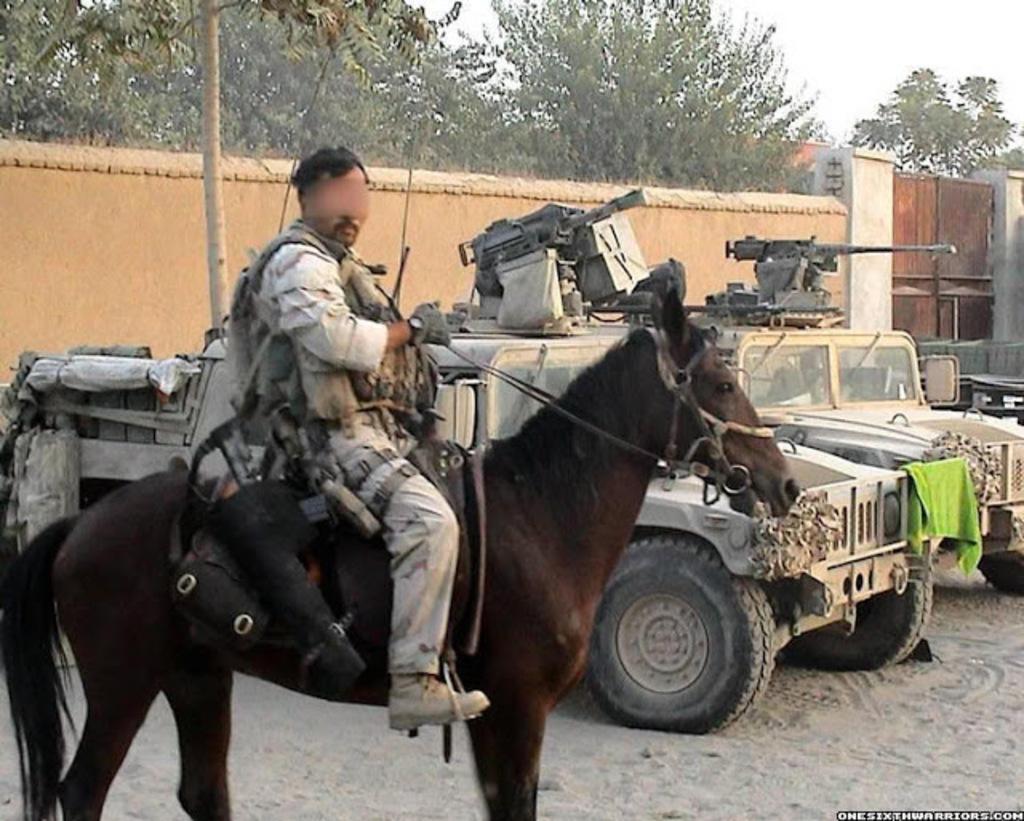Can you describe this image briefly? In the foreground of the picture there is a person riding horse. In the center of the picture there are vehicles, wall, gate and tree. In the background there are trees and building. At the bottom there is sand. 